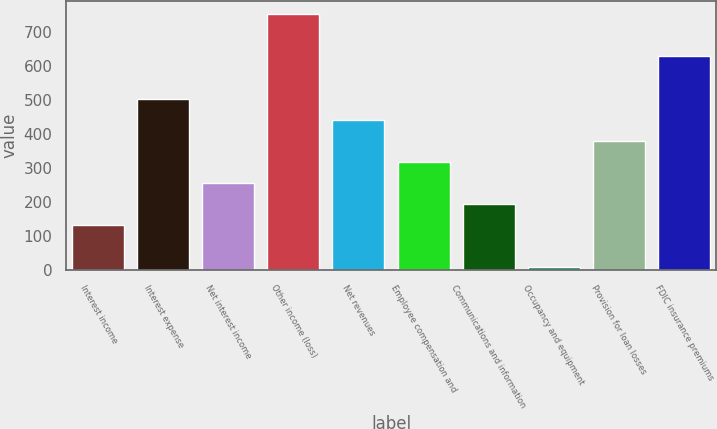Convert chart to OTSL. <chart><loc_0><loc_0><loc_500><loc_500><bar_chart><fcel>Interest income<fcel>Interest expense<fcel>Net interest income<fcel>Other income (loss)<fcel>Net revenues<fcel>Employee compensation and<fcel>Communications and information<fcel>Occupancy and equipment<fcel>Provision for loan losses<fcel>FDIC insurance premiums<nl><fcel>132.2<fcel>504.8<fcel>256.4<fcel>753.2<fcel>442.7<fcel>318.5<fcel>194.3<fcel>8<fcel>380.6<fcel>629<nl></chart> 